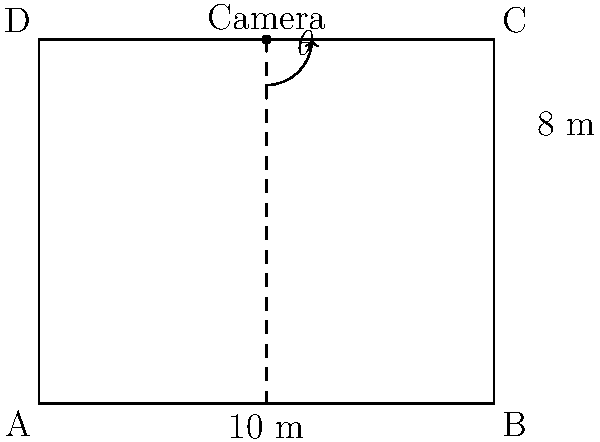A livestreaming camera is positioned at the center of the back wall of a rectangular sanctuary, as shown in the diagram. The sanctuary measures 10 meters wide and 8 meters long. To capture the entire width of the sanctuary, what should be the optimal angle $\theta$ (in degrees) for the camera to be tilted downward from the horizontal? To solve this problem, we'll use trigonometry. Let's break it down step-by-step:

1) First, we need to identify the right triangle formed by the camera's line of sight:
   - The base of the triangle is half the width of the sanctuary (5 meters)
   - The height of the triangle is the height of the camera (8 meters)

2) We can use the tangent function to find the angle $\theta$:

   $$\tan(\theta) = \frac{\text{opposite}}{\text{adjacent}} = \frac{8}{5}$$

3) To find $\theta$, we need to use the inverse tangent (arctangent) function:

   $$\theta = \arctan(\frac{8}{5})$$

4) Using a calculator or programming function, we can compute this value:

   $$\theta \approx 57.99^\circ$$

5) However, this is the angle from the horizontal to the camera's line of sight. The question asks for the angle the camera should be tilted downward, which is the complement of this angle:

   $$\text{Tilt angle} = 90^\circ - 57.99^\circ \approx 32.01^\circ$$

6) Rounding to two decimal places:

   $$\text{Tilt angle} \approx 32.01^\circ$$

This angle will allow the camera to capture the entire width of the sanctuary.
Answer: $32.01^\circ$ 